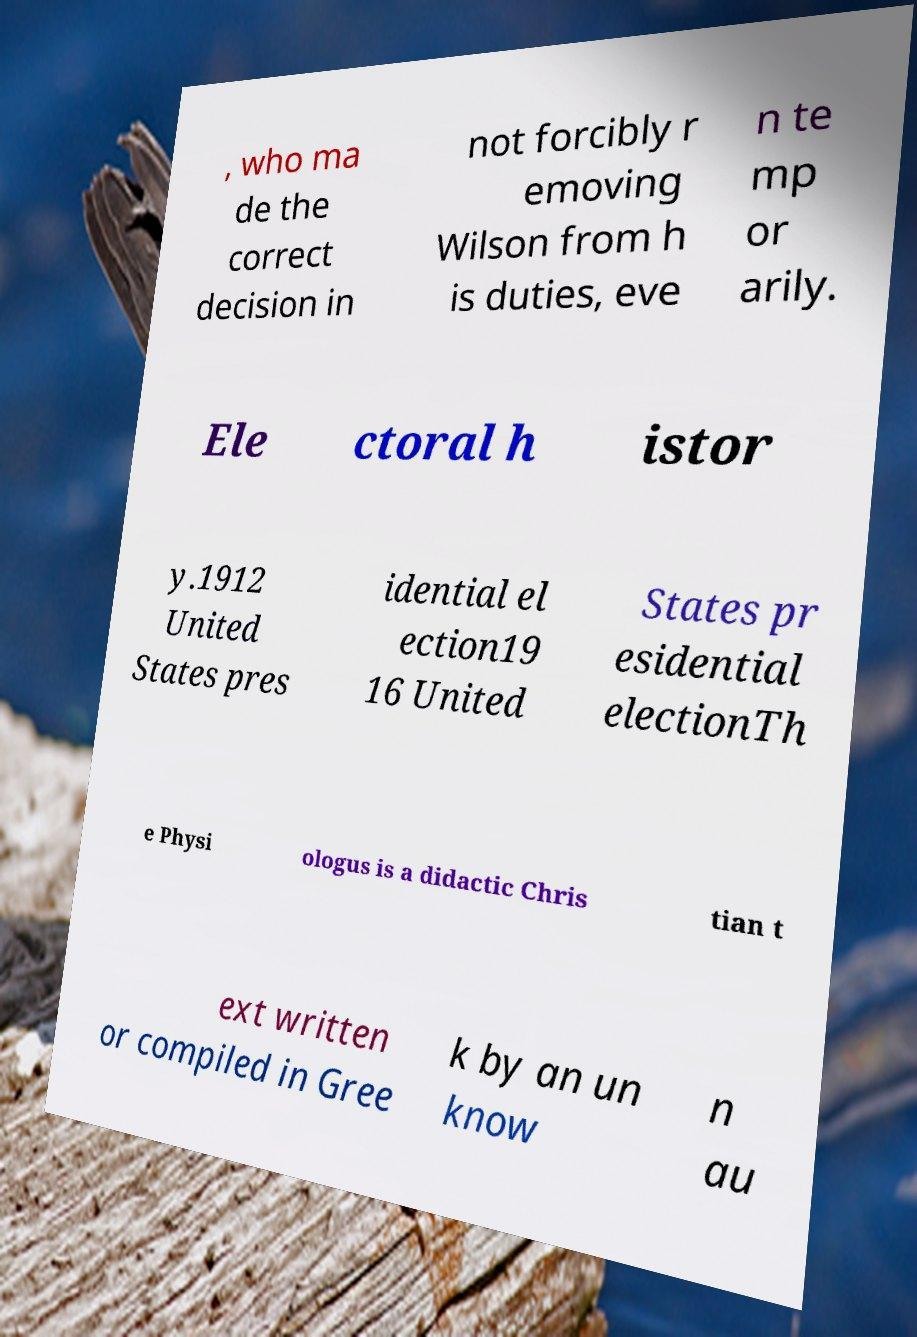Could you extract and type out the text from this image? , who ma de the correct decision in not forcibly r emoving Wilson from h is duties, eve n te mp or arily. Ele ctoral h istor y.1912 United States pres idential el ection19 16 United States pr esidential electionTh e Physi ologus is a didactic Chris tian t ext written or compiled in Gree k by an un know n au 